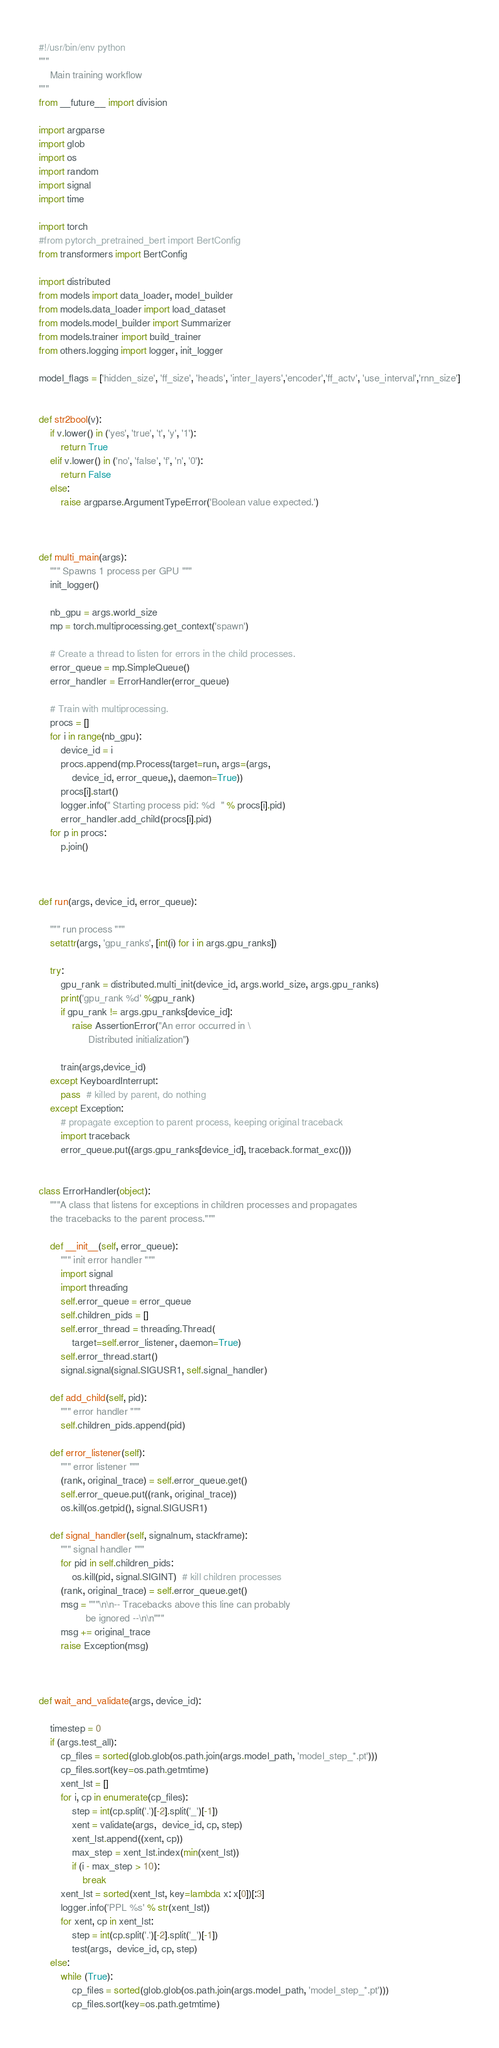Convert code to text. <code><loc_0><loc_0><loc_500><loc_500><_Python_>#!/usr/bin/env python
"""
    Main training workflow
"""
from __future__ import division

import argparse
import glob
import os
import random
import signal
import time

import torch
#from pytorch_pretrained_bert import BertConfig
from transformers import BertConfig

import distributed
from models import data_loader, model_builder
from models.data_loader import load_dataset
from models.model_builder import Summarizer
from models.trainer import build_trainer
from others.logging import logger, init_logger

model_flags = ['hidden_size', 'ff_size', 'heads', 'inter_layers','encoder','ff_actv', 'use_interval','rnn_size']


def str2bool(v):
    if v.lower() in ('yes', 'true', 't', 'y', '1'):
        return True
    elif v.lower() in ('no', 'false', 'f', 'n', '0'):
        return False
    else:
        raise argparse.ArgumentTypeError('Boolean value expected.')



def multi_main(args):
    """ Spawns 1 process per GPU """
    init_logger()

    nb_gpu = args.world_size
    mp = torch.multiprocessing.get_context('spawn')

    # Create a thread to listen for errors in the child processes.
    error_queue = mp.SimpleQueue()
    error_handler = ErrorHandler(error_queue)

    # Train with multiprocessing.
    procs = []
    for i in range(nb_gpu):
        device_id = i
        procs.append(mp.Process(target=run, args=(args,
            device_id, error_queue,), daemon=True))
        procs[i].start()
        logger.info(" Starting process pid: %d  " % procs[i].pid)
        error_handler.add_child(procs[i].pid)
    for p in procs:
        p.join()



def run(args, device_id, error_queue):

    """ run process """
    setattr(args, 'gpu_ranks', [int(i) for i in args.gpu_ranks])

    try:
        gpu_rank = distributed.multi_init(device_id, args.world_size, args.gpu_ranks)
        print('gpu_rank %d' %gpu_rank)
        if gpu_rank != args.gpu_ranks[device_id]:
            raise AssertionError("An error occurred in \
                  Distributed initialization")

        train(args,device_id)
    except KeyboardInterrupt:
        pass  # killed by parent, do nothing
    except Exception:
        # propagate exception to parent process, keeping original traceback
        import traceback
        error_queue.put((args.gpu_ranks[device_id], traceback.format_exc()))


class ErrorHandler(object):
    """A class that listens for exceptions in children processes and propagates
    the tracebacks to the parent process."""

    def __init__(self, error_queue):
        """ init error handler """
        import signal
        import threading
        self.error_queue = error_queue
        self.children_pids = []
        self.error_thread = threading.Thread(
            target=self.error_listener, daemon=True)
        self.error_thread.start()
        signal.signal(signal.SIGUSR1, self.signal_handler)

    def add_child(self, pid):
        """ error handler """
        self.children_pids.append(pid)

    def error_listener(self):
        """ error listener """
        (rank, original_trace) = self.error_queue.get()
        self.error_queue.put((rank, original_trace))
        os.kill(os.getpid(), signal.SIGUSR1)

    def signal_handler(self, signalnum, stackframe):
        """ signal handler """
        for pid in self.children_pids:
            os.kill(pid, signal.SIGINT)  # kill children processes
        (rank, original_trace) = self.error_queue.get()
        msg = """\n\n-- Tracebacks above this line can probably
                 be ignored --\n\n"""
        msg += original_trace
        raise Exception(msg)



def wait_and_validate(args, device_id):

    timestep = 0
    if (args.test_all):
        cp_files = sorted(glob.glob(os.path.join(args.model_path, 'model_step_*.pt')))
        cp_files.sort(key=os.path.getmtime)
        xent_lst = []
        for i, cp in enumerate(cp_files):
            step = int(cp.split('.')[-2].split('_')[-1])
            xent = validate(args,  device_id, cp, step)
            xent_lst.append((xent, cp))
            max_step = xent_lst.index(min(xent_lst))
            if (i - max_step > 10):
                break
        xent_lst = sorted(xent_lst, key=lambda x: x[0])[:3]
        logger.info('PPL %s' % str(xent_lst))
        for xent, cp in xent_lst:
            step = int(cp.split('.')[-2].split('_')[-1])
            test(args,  device_id, cp, step)
    else:
        while (True):
            cp_files = sorted(glob.glob(os.path.join(args.model_path, 'model_step_*.pt')))
            cp_files.sort(key=os.path.getmtime)</code> 